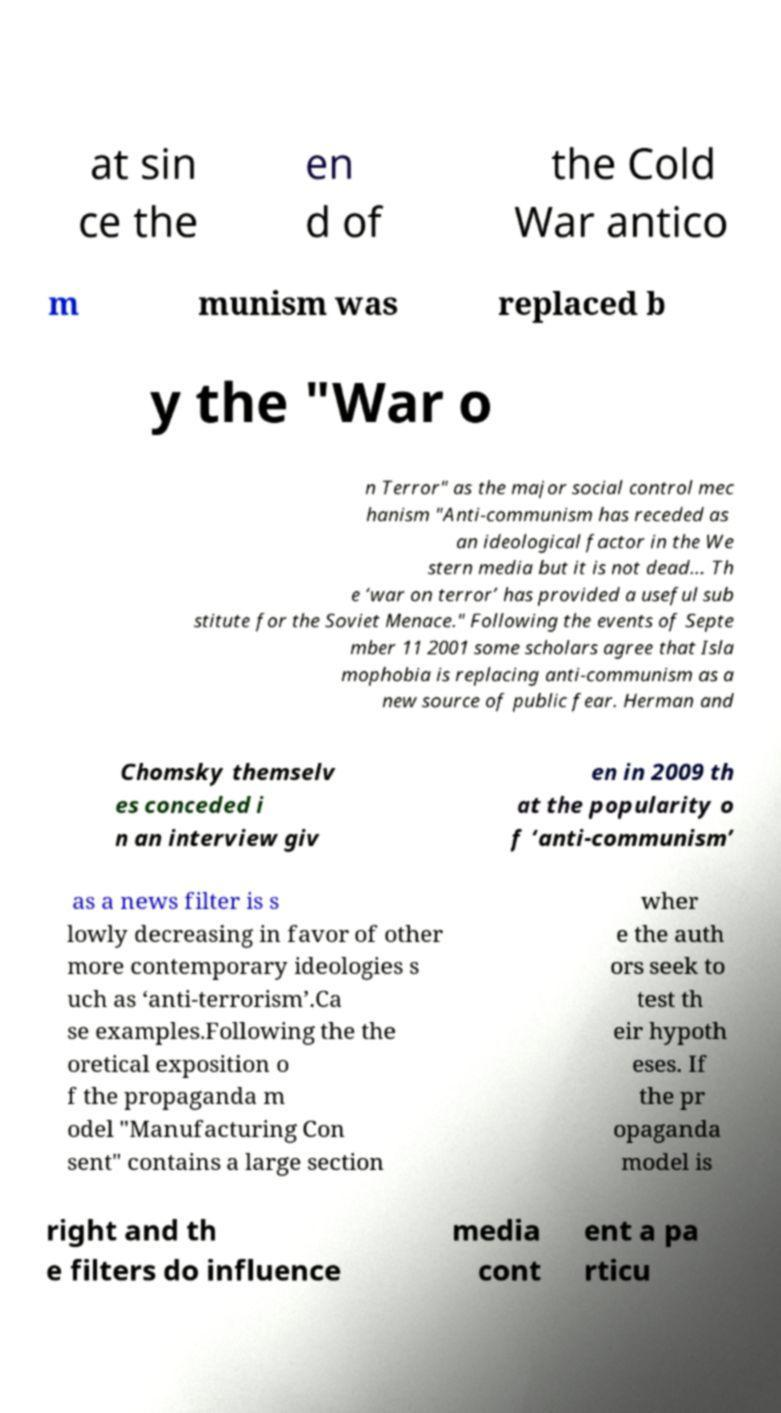What messages or text are displayed in this image? I need them in a readable, typed format. at sin ce the en d of the Cold War antico m munism was replaced b y the "War o n Terror" as the major social control mec hanism "Anti-communism has receded as an ideological factor in the We stern media but it is not dead... Th e ‘war on terror’ has provided a useful sub stitute for the Soviet Menace." Following the events of Septe mber 11 2001 some scholars agree that Isla mophobia is replacing anti-communism as a new source of public fear. Herman and Chomsky themselv es conceded i n an interview giv en in 2009 th at the popularity o f ‘anti-communism’ as a news filter is s lowly decreasing in favor of other more contemporary ideologies s uch as ‘anti-terrorism’.Ca se examples.Following the the oretical exposition o f the propaganda m odel "Manufacturing Con sent" contains a large section wher e the auth ors seek to test th eir hypoth eses. If the pr opaganda model is right and th e filters do influence media cont ent a pa rticu 